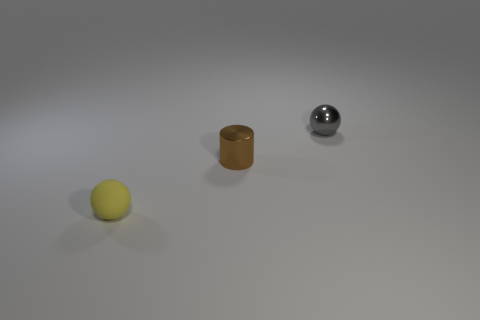There is a small shiny object that is to the left of the gray sphere; how many gray spheres are behind it?
Your answer should be compact. 1. Is the size of the ball that is behind the small matte thing the same as the ball that is to the left of the shiny cylinder?
Make the answer very short. Yes. What number of big cyan shiny objects are there?
Provide a succinct answer. 0. How many small yellow spheres have the same material as the gray ball?
Offer a terse response. 0. Is the number of gray metal balls that are on the left side of the small matte sphere the same as the number of large gray rubber cylinders?
Ensure brevity in your answer.  Yes. There is a brown metallic thing; is it the same size as the shiny thing that is behind the tiny brown cylinder?
Give a very brief answer. Yes. Is there anything else that has the same size as the shiny ball?
Your response must be concise. Yes. What number of other objects are there of the same shape as the brown thing?
Provide a short and direct response. 0. Is the yellow matte sphere the same size as the metal ball?
Offer a terse response. Yes. Are any yellow objects visible?
Give a very brief answer. Yes. 